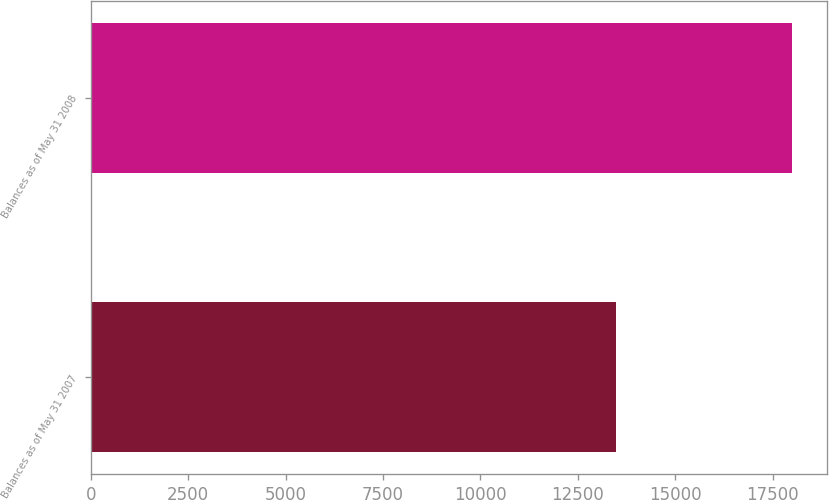<chart> <loc_0><loc_0><loc_500><loc_500><bar_chart><fcel>Balances as of May 31 2007<fcel>Balances as of May 31 2008<nl><fcel>13479<fcel>17991<nl></chart> 